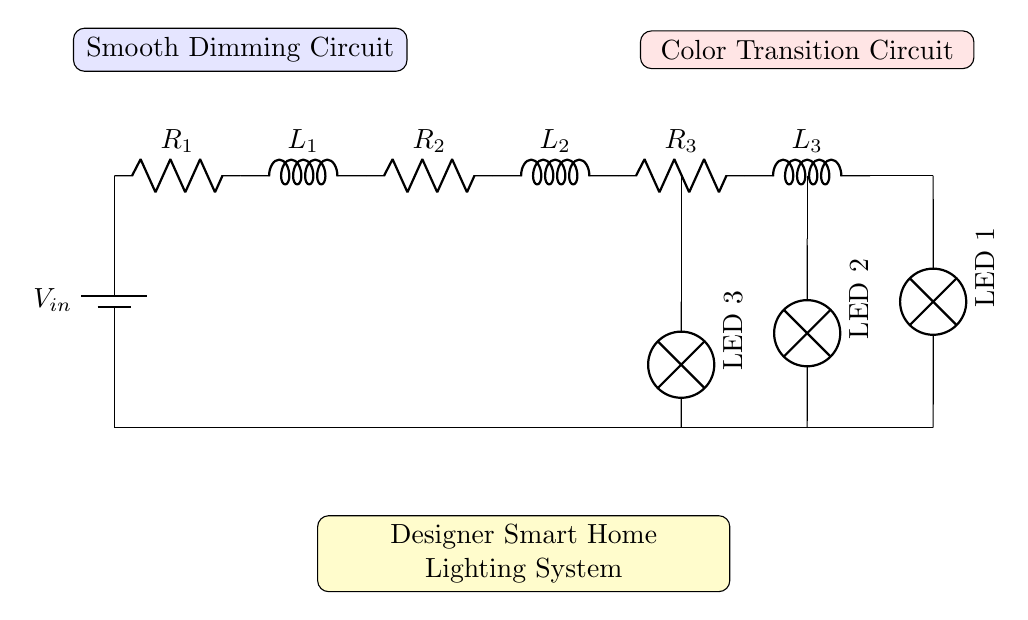What is the input voltage for this circuit? The input voltage is denoted by V in the circuit diagram. It is situated on the left side where the supply connects to the resistors and inductors.
Answer: V in How many resistors are present in the circuit? Upon visual inspection, there are three resistors identified in the circuit, labeled R1, R2, and R3, indicating their positions in the circuit.
Answer: 3 What components are used to achieve color transitions? The circuit contains inductors L2 and L3, which work in conjunction with the LEDs labeled LED 2 and LED 3 to provide color transitioning effects.
Answer: L2, L3 What is the purpose of the inductors in the dimming circuit? The inductors, specifically L1, in the circuit facilitate the smooth dimming function by controlling the rate of change of current flowing through the circuit, preventing abrupt changes in brightness.
Answer: Smooth dimming What is the function of the yellow box in the diagram? The yellow box indicates the designer smart home lighting system, representing the overarching application of the components, which are arranged to achieve smooth dimming and color transitions within the system.
Answer: Designer Smart Home Lighting System What is the effect of the series resistors in this circuit? Series resistors, such as R1, R2, and R3, limit the current flowing through the inductors and LEDs, ensuring that they operate safely and within their power ratings, achieving optimal light output.
Answer: Current limiting 